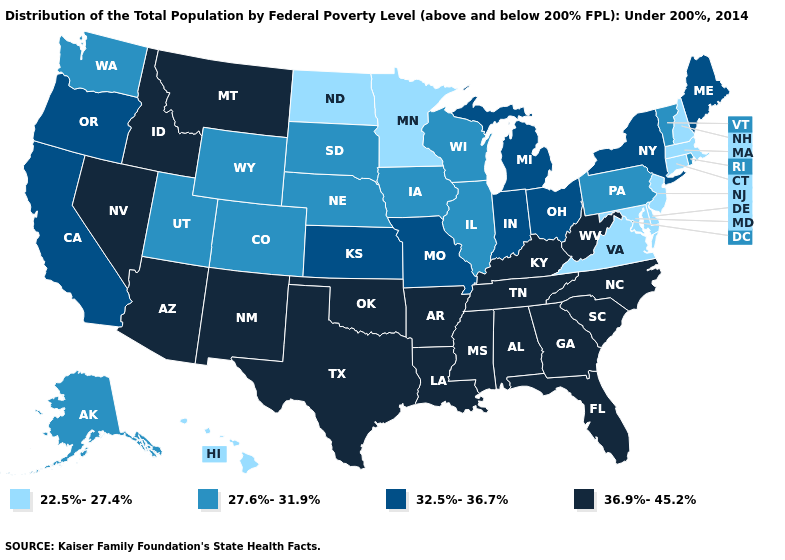Name the states that have a value in the range 36.9%-45.2%?
Be succinct. Alabama, Arizona, Arkansas, Florida, Georgia, Idaho, Kentucky, Louisiana, Mississippi, Montana, Nevada, New Mexico, North Carolina, Oklahoma, South Carolina, Tennessee, Texas, West Virginia. What is the value of Nevada?
Quick response, please. 36.9%-45.2%. Name the states that have a value in the range 32.5%-36.7%?
Answer briefly. California, Indiana, Kansas, Maine, Michigan, Missouri, New York, Ohio, Oregon. Name the states that have a value in the range 22.5%-27.4%?
Be succinct. Connecticut, Delaware, Hawaii, Maryland, Massachusetts, Minnesota, New Hampshire, New Jersey, North Dakota, Virginia. Does Maryland have the lowest value in the South?
Give a very brief answer. Yes. Does Connecticut have the lowest value in the USA?
Be succinct. Yes. How many symbols are there in the legend?
Answer briefly. 4. What is the lowest value in the USA?
Be succinct. 22.5%-27.4%. Is the legend a continuous bar?
Keep it brief. No. Does Florida have the highest value in the USA?
Quick response, please. Yes. How many symbols are there in the legend?
Answer briefly. 4. Does Maryland have a lower value than North Dakota?
Short answer required. No. Name the states that have a value in the range 22.5%-27.4%?
Concise answer only. Connecticut, Delaware, Hawaii, Maryland, Massachusetts, Minnesota, New Hampshire, New Jersey, North Dakota, Virginia. 